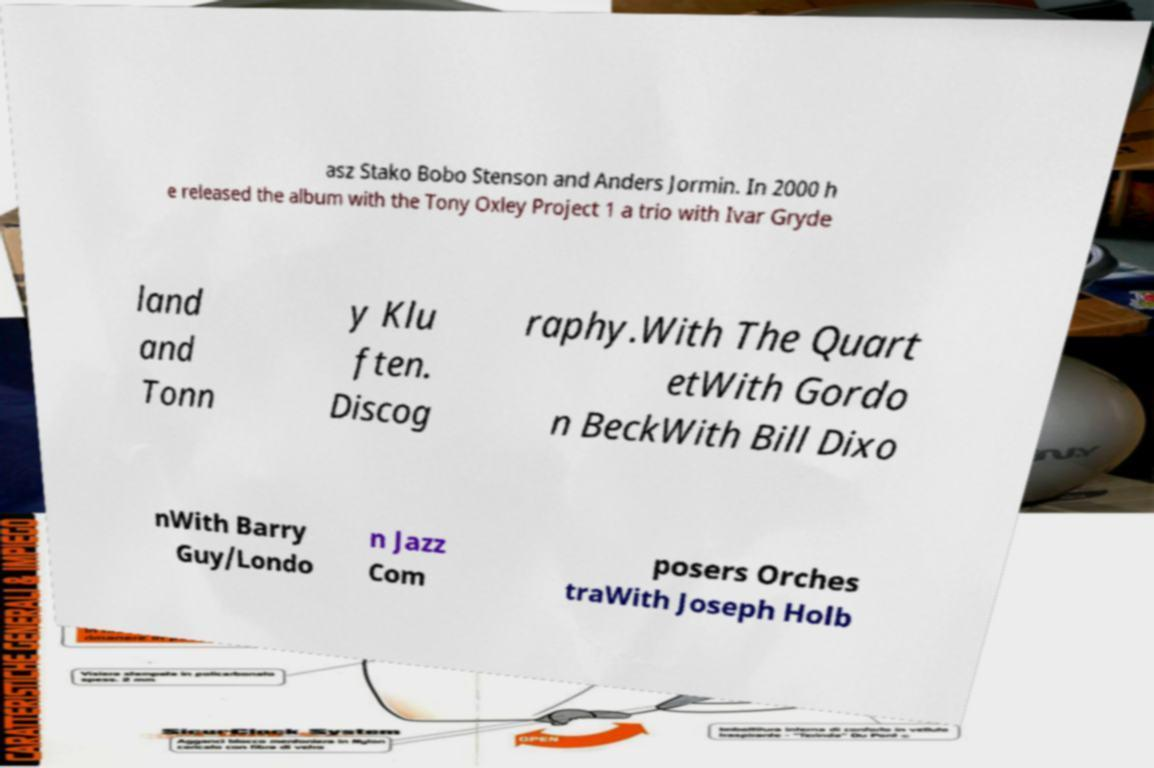What messages or text are displayed in this image? I need them in a readable, typed format. asz Stako Bobo Stenson and Anders Jormin. In 2000 h e released the album with the Tony Oxley Project 1 a trio with Ivar Gryde land and Tonn y Klu ften. Discog raphy.With The Quart etWith Gordo n BeckWith Bill Dixo nWith Barry Guy/Londo n Jazz Com posers Orches traWith Joseph Holb 